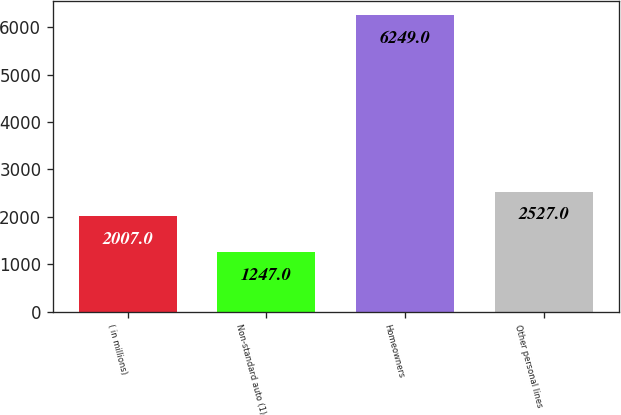Convert chart. <chart><loc_0><loc_0><loc_500><loc_500><bar_chart><fcel>( in millions)<fcel>Non-standard auto (1)<fcel>Homeowners<fcel>Other personal lines<nl><fcel>2007<fcel>1247<fcel>6249<fcel>2527<nl></chart> 